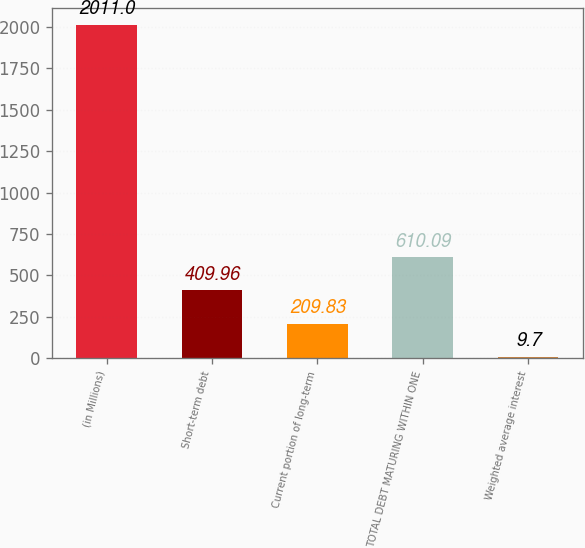Convert chart to OTSL. <chart><loc_0><loc_0><loc_500><loc_500><bar_chart><fcel>(in Millions)<fcel>Short-term debt<fcel>Current portion of long-term<fcel>TOTAL DEBT MATURING WITHIN ONE<fcel>Weighted average interest<nl><fcel>2011<fcel>409.96<fcel>209.83<fcel>610.09<fcel>9.7<nl></chart> 